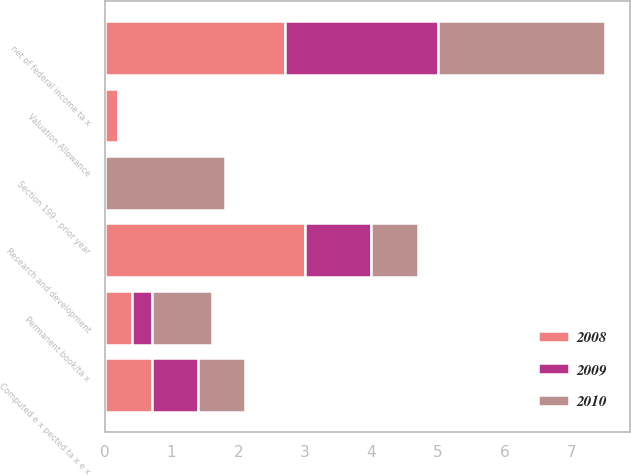Convert chart to OTSL. <chart><loc_0><loc_0><loc_500><loc_500><stacked_bar_chart><ecel><fcel>Computed e x pected ta x e x<fcel>net of federal income ta x<fcel>Research and development<fcel>Permanent book/ta x<fcel>Section 199 - prior year<fcel>Valuation Allowance<nl><fcel>2010<fcel>0.7<fcel>2.5<fcel>0.7<fcel>0.9<fcel>1.8<fcel>0<nl><fcel>2008<fcel>0.7<fcel>2.7<fcel>3<fcel>0.4<fcel>0<fcel>0.2<nl><fcel>2009<fcel>0.7<fcel>2.3<fcel>1<fcel>0.3<fcel>0<fcel>0<nl></chart> 